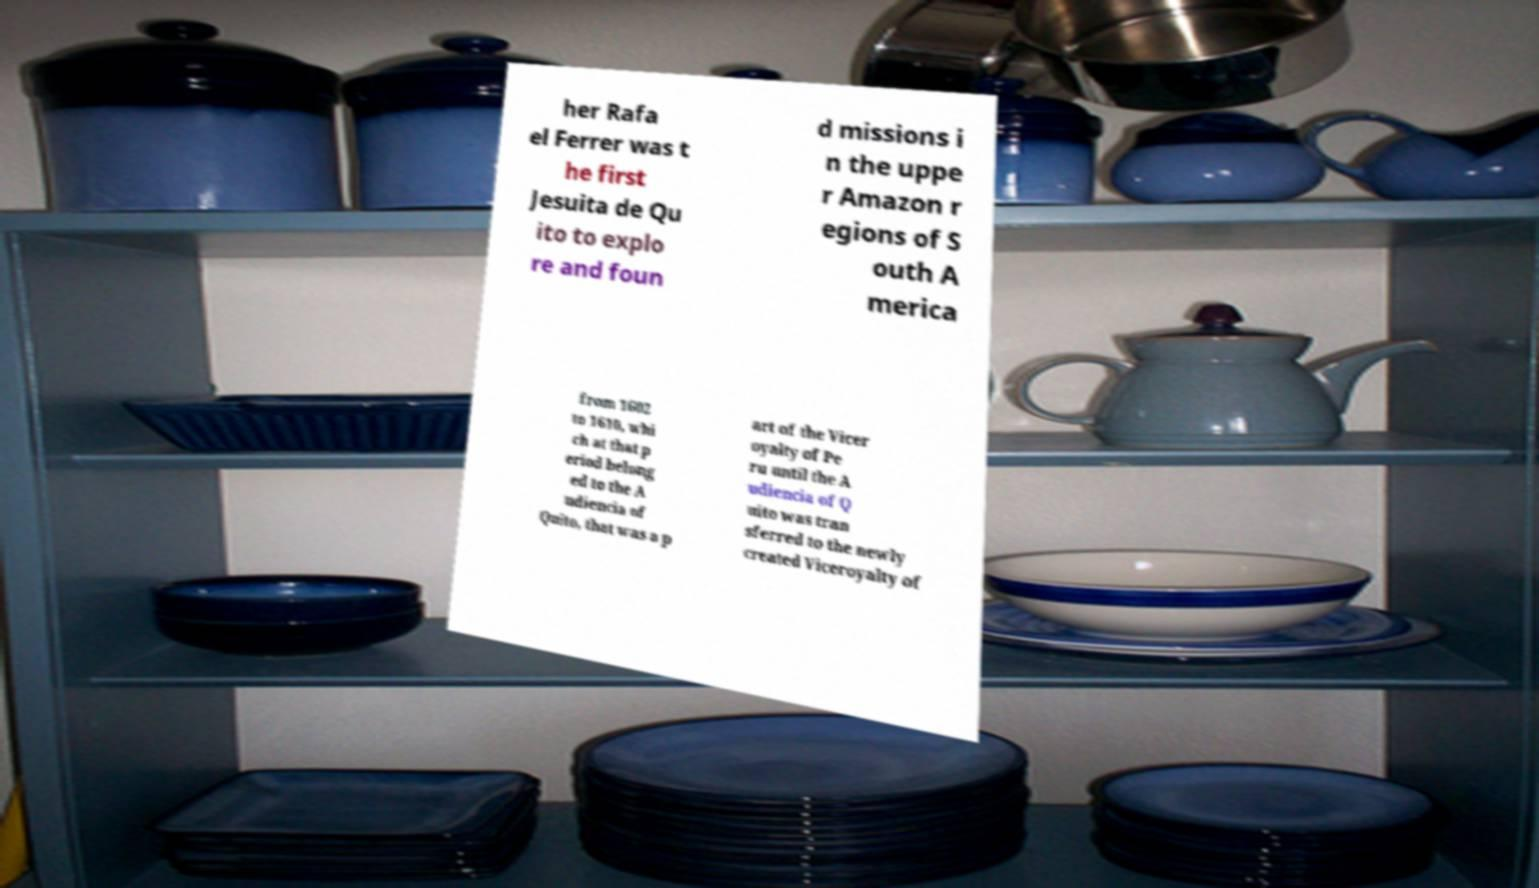Can you read and provide the text displayed in the image?This photo seems to have some interesting text. Can you extract and type it out for me? her Rafa el Ferrer was t he first Jesuita de Qu ito to explo re and foun d missions i n the uppe r Amazon r egions of S outh A merica from 1602 to 1610, whi ch at that p eriod belong ed to the A udiencia of Quito, that was a p art of the Vicer oyalty of Pe ru until the A udiencia of Q uito was tran sferred to the newly created Viceroyalty of 